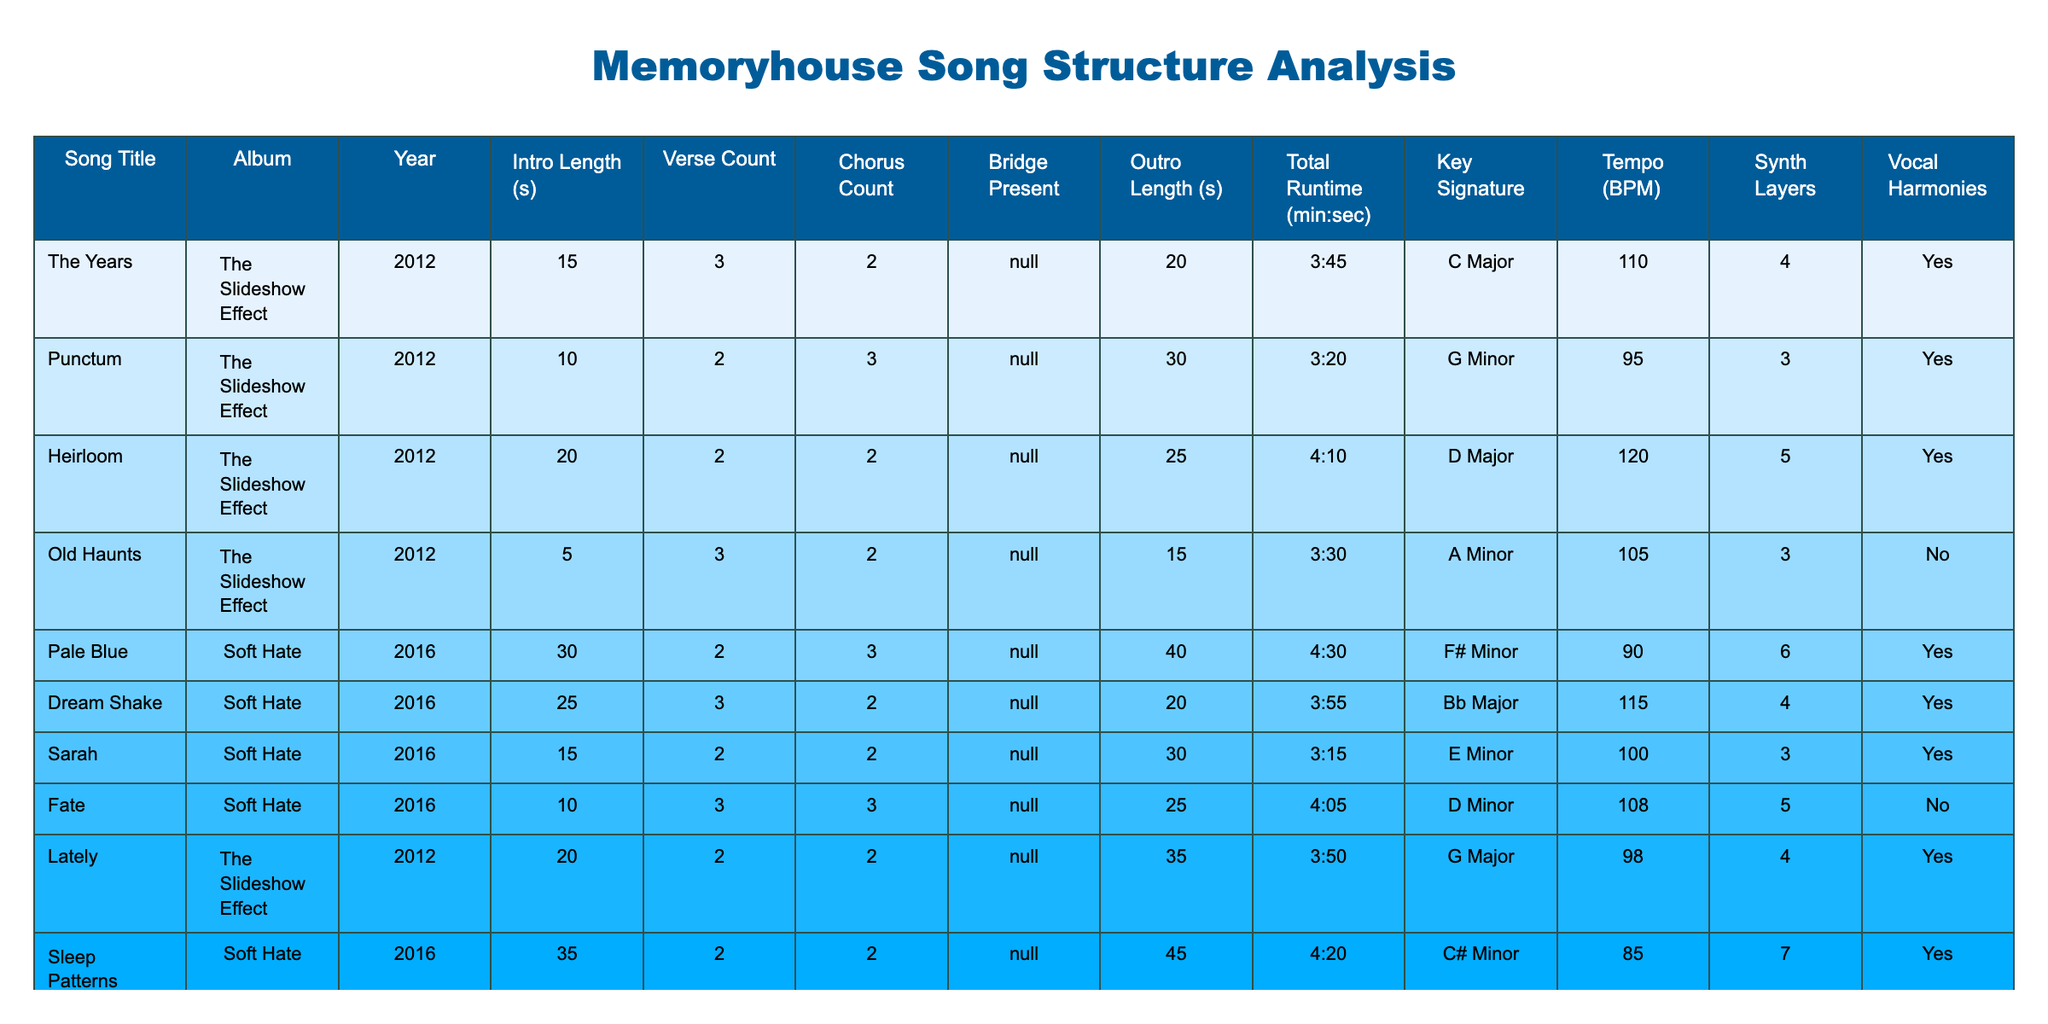What is the total runtime of "Dream Shake"? Looking at the "Total Runtime" column for "Dream Shake," the entry is 3:55.
Answer: 3:55 Which song from the album "Soft Hate" has the longest intro? In the "Soft Hate" section, the introduction lengths for each song are compared, and "Sleep Patterns" has the longest intro at 35 seconds.
Answer: Sleep Patterns How many songs feature a bridge? By reviewing the "Bridge Present" column, it can be counted that 4 songs have a bridge (marked "Yes").
Answer: 4 What is the average tempo of songs from "The Slideshow Effect"? The tempos listed for the songs from "The Slideshow Effect" are 110, 95, 120, 105, and 98. Adding these gives 628, and dividing by 5 results in an average of 125.6 BPM.
Answer: 125.6 BPM Which song has the highest number of vocal harmonies, and does it feature a bridge? Upon examining the "Vocal Harmonies" and "Bridge Present" columns, "Sleep Patterns" has the highest number of vocal harmonies (7) and it also features a bridge ("Yes").
Answer: Sleep Patterns, Yes What is the key signature of the song with the longest outro? Checking the "Outro Length" column, "Pale Blue" has the longest outro at 40 seconds. Its key signature is F# Minor.
Answer: F# Minor Which album features the most songs, and how many songs does it contain? "The Slideshow Effect" has 5 songs listed, while "Soft Hate" has only 4 songs. Therefore, "The Slideshow Effect" has the most songs.
Answer: The Slideshow Effect, 5 songs Is there a song with a chorus count of more than 3 that features a bridge? By looking at the "Chorus Count" and "Bridge Present" columns, "Fate" has a chorus count of 3 and features a bridge, while no song has a chorus count of more than 3 and a bridge.
Answer: No Which song from the "Soft Hate" album has the lowest tempo and what is it? In the "Soft Hate" section, "Sleep Patterns" has a tempo of 85 BPM, which is the lowest among that set.
Answer: 85 BPM What correlation can be observed between synth layers and vocal harmonies in the album "The Slideshow Effect"? Analyzing the songs from "The Slideshow Effect," there are various combinations of synth layers and vocal harmonies. A closer look reveals that songs with more synth layers generally tend to have vocal harmonies as well, but this isn't consistent across all songs.
Answer: General positive correlation 